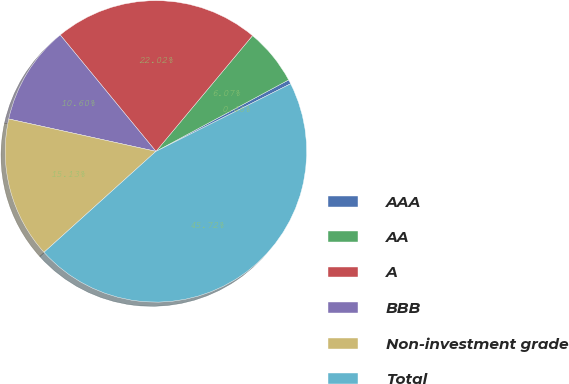Convert chart. <chart><loc_0><loc_0><loc_500><loc_500><pie_chart><fcel>AAA<fcel>AA<fcel>A<fcel>BBB<fcel>Non-investment grade<fcel>Total<nl><fcel>0.46%<fcel>6.07%<fcel>22.02%<fcel>10.6%<fcel>15.13%<fcel>45.72%<nl></chart> 